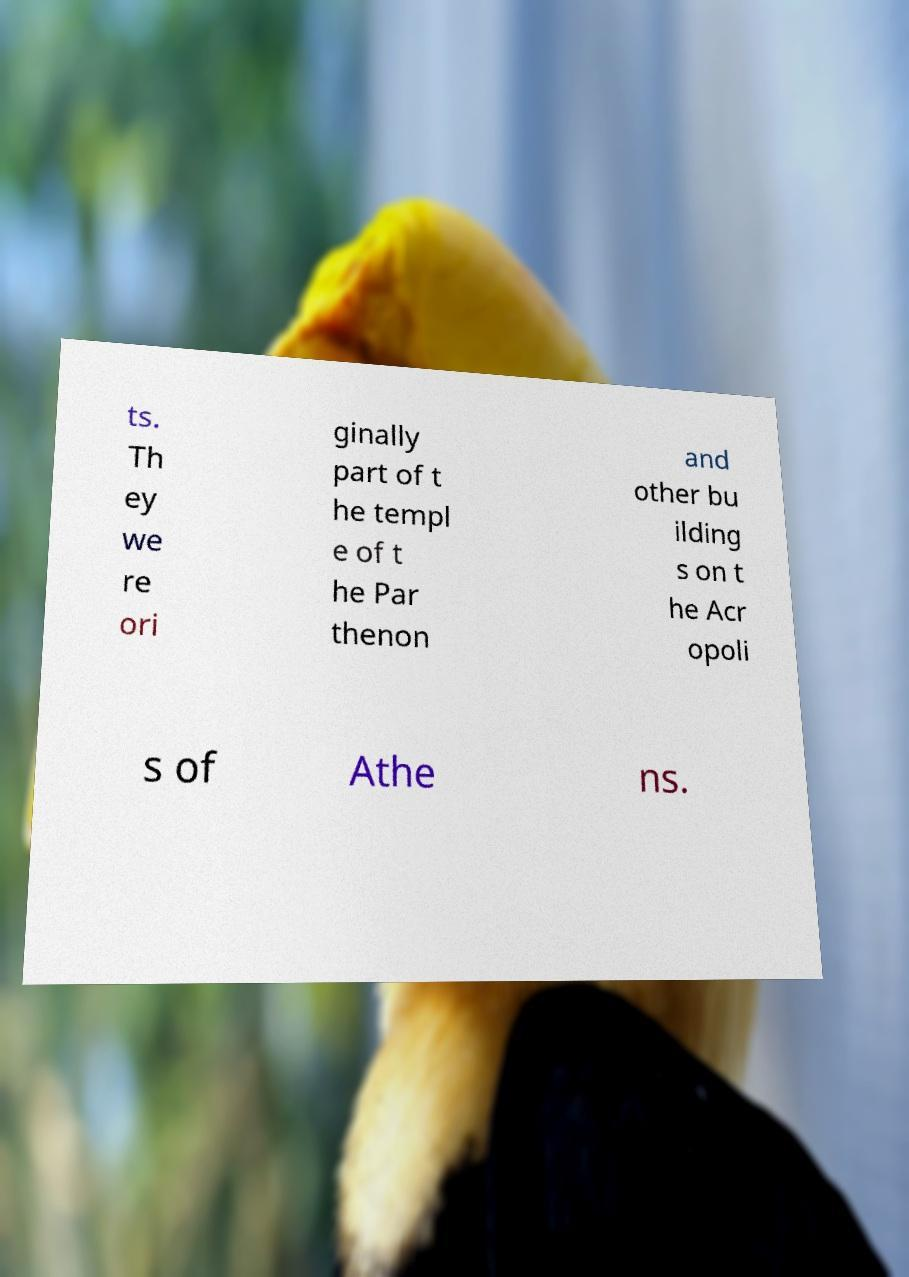Could you assist in decoding the text presented in this image and type it out clearly? ts. Th ey we re ori ginally part of t he templ e of t he Par thenon and other bu ilding s on t he Acr opoli s of Athe ns. 